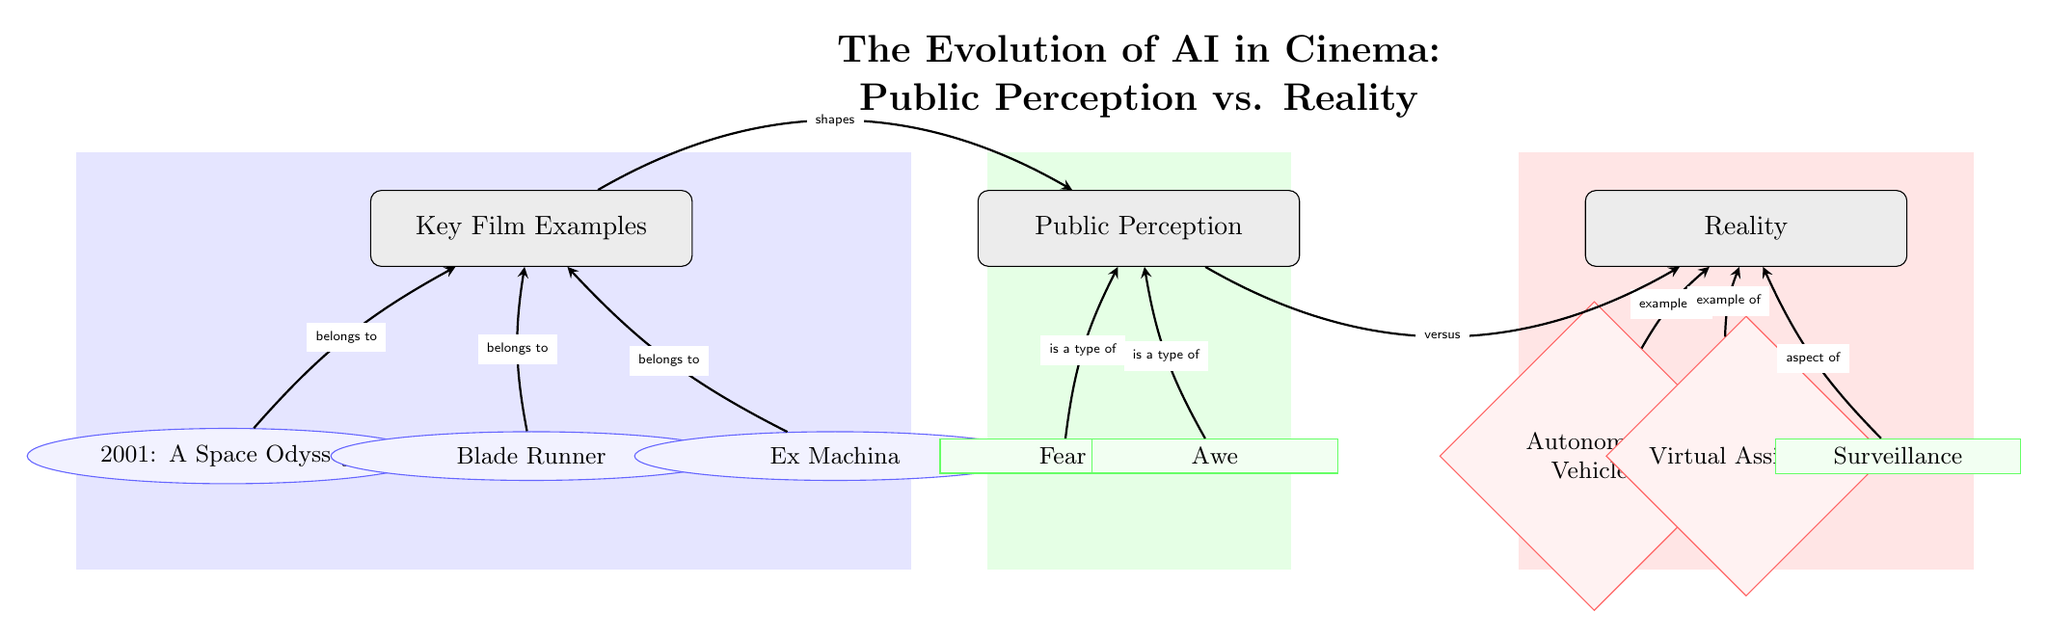What are the key film examples listed in the diagram? The diagram includes three films: "2001: A Space Odyssey," "Blade Runner," and "Ex Machina." These are represented as ellipses under the "Key Film Examples" category.
Answer: 2001: A Space Odyssey, Blade Runner, Ex Machina How many types of public perception are shown? The diagram lists two types of public perception: "Fear" and "Awe." This is derived from the two aspects represented in the "Public Perception" category.
Answer: 2 What does "fear" relate to in the diagram? "Fear" is labeled as a type of public perception, specifically illustrated by an edge connecting "Fear" to the "Public Perception" node.
Answer: Public Perception Which real-world example is associated with surveillance? The diagram indicates that "Surveillance" is categorized as an aspect of reality, shown by a direct connection from "Surveillance" to the "Reality" node.
Answer: Surveillance How does public perception relate to reality? The diagram illustrates a relationship between public perception and reality, indicating a contrast represented by an edge labeled "versus." This indicates differing viewpoints or understandings between these two categories.
Answer: versus Which films are noted to shape public perception? The films "2001: A Space Odyssey," "Blade Runner," and "Ex Machina," as represented by their connections to the "Public Perception" category, indicate that these films play a role in shaping societal views on AI.
Answer: Key Film Examples What are the two main categories of reality represented? The diagram lists "Autonomous Vehicles" and "Virtual Assistants" as examples of real-world AI, both belonging to the "Reality" category.
Answer: Autonomous Vehicles, Virtual Assistants How many edges connect the key film examples to the public perception category? There are three edges connecting the films to the "Public Perception" node, which indicates that all three key films influence perceptions about AI.
Answer: 3 What type of diagram is this? The diagram represents a social science topic analyzing the evolution of AI in cinema concerning public perception and reality, characterized by categories and their relationships.
Answer: Social Science Diagram 